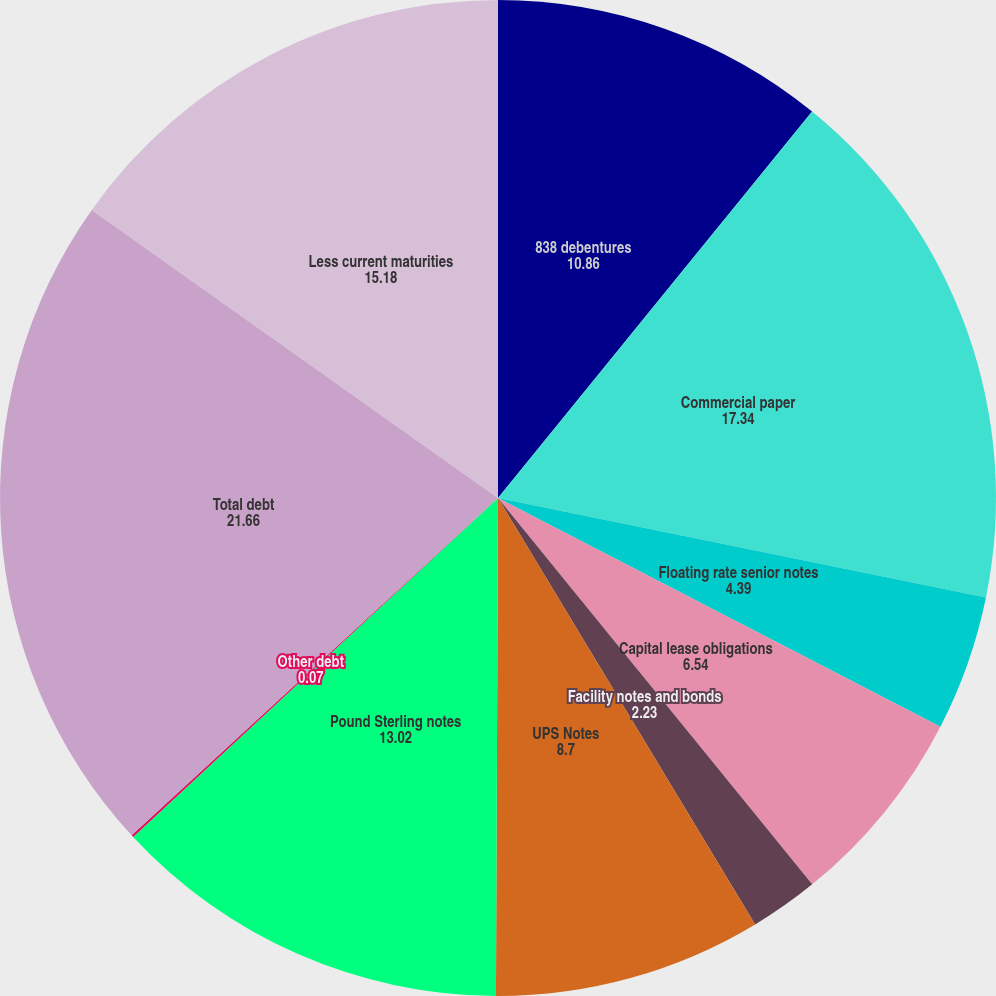<chart> <loc_0><loc_0><loc_500><loc_500><pie_chart><fcel>838 debentures<fcel>Commercial paper<fcel>Floating rate senior notes<fcel>Capital lease obligations<fcel>Facility notes and bonds<fcel>UPS Notes<fcel>Pound Sterling notes<fcel>Other debt<fcel>Total debt<fcel>Less current maturities<nl><fcel>10.86%<fcel>17.34%<fcel>4.39%<fcel>6.54%<fcel>2.23%<fcel>8.7%<fcel>13.02%<fcel>0.07%<fcel>21.66%<fcel>15.18%<nl></chart> 